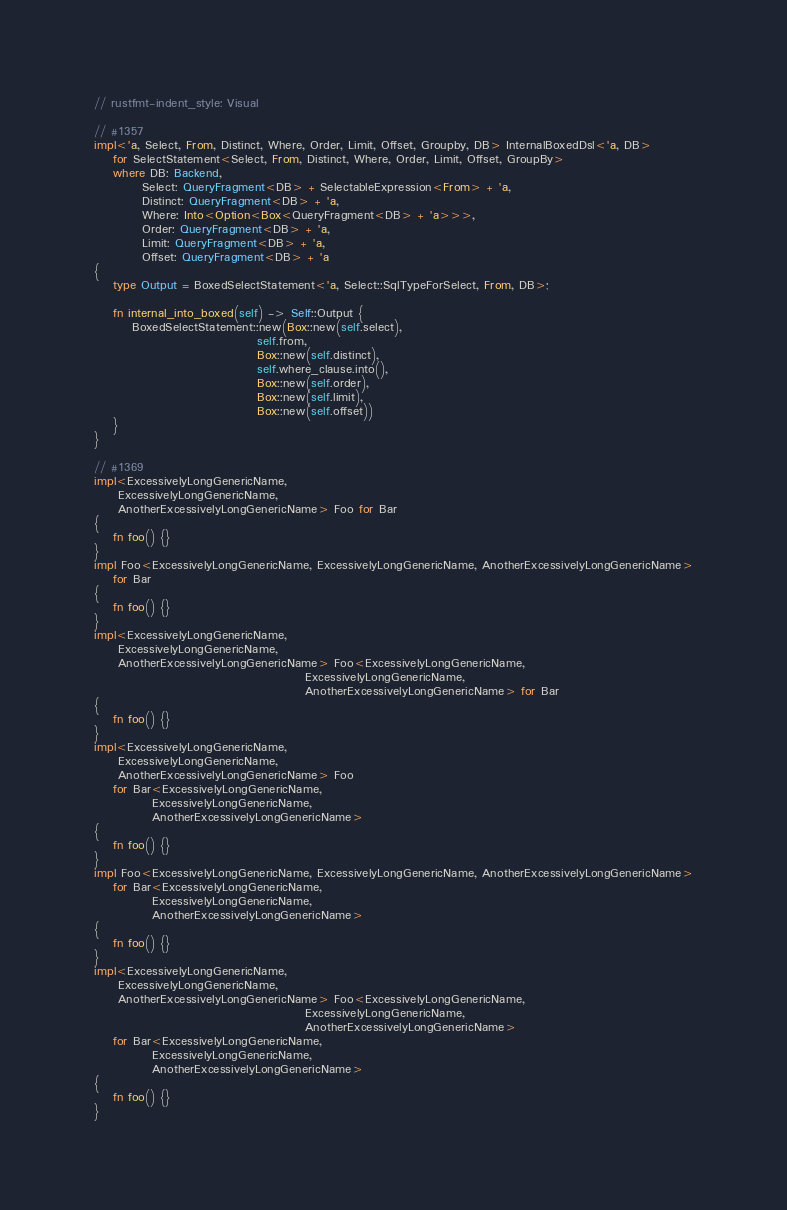<code> <loc_0><loc_0><loc_500><loc_500><_Rust_>// rustfmt-indent_style: Visual

// #1357
impl<'a, Select, From, Distinct, Where, Order, Limit, Offset, Groupby, DB> InternalBoxedDsl<'a, DB>
    for SelectStatement<Select, From, Distinct, Where, Order, Limit, Offset, GroupBy>
    where DB: Backend,
          Select: QueryFragment<DB> + SelectableExpression<From> + 'a,
          Distinct: QueryFragment<DB> + 'a,
          Where: Into<Option<Box<QueryFragment<DB> + 'a>>>,
          Order: QueryFragment<DB> + 'a,
          Limit: QueryFragment<DB> + 'a,
          Offset: QueryFragment<DB> + 'a
{
    type Output = BoxedSelectStatement<'a, Select::SqlTypeForSelect, From, DB>;

    fn internal_into_boxed(self) -> Self::Output {
        BoxedSelectStatement::new(Box::new(self.select),
                                  self.from,
                                  Box::new(self.distinct),
                                  self.where_clause.into(),
                                  Box::new(self.order),
                                  Box::new(self.limit),
                                  Box::new(self.offset))
    }
}

// #1369
impl<ExcessivelyLongGenericName,
     ExcessivelyLongGenericName,
     AnotherExcessivelyLongGenericName> Foo for Bar
{
    fn foo() {}
}
impl Foo<ExcessivelyLongGenericName, ExcessivelyLongGenericName, AnotherExcessivelyLongGenericName>
    for Bar
{
    fn foo() {}
}
impl<ExcessivelyLongGenericName,
     ExcessivelyLongGenericName,
     AnotherExcessivelyLongGenericName> Foo<ExcessivelyLongGenericName,
                                            ExcessivelyLongGenericName,
                                            AnotherExcessivelyLongGenericName> for Bar
{
    fn foo() {}
}
impl<ExcessivelyLongGenericName,
     ExcessivelyLongGenericName,
     AnotherExcessivelyLongGenericName> Foo
    for Bar<ExcessivelyLongGenericName,
            ExcessivelyLongGenericName,
            AnotherExcessivelyLongGenericName>
{
    fn foo() {}
}
impl Foo<ExcessivelyLongGenericName, ExcessivelyLongGenericName, AnotherExcessivelyLongGenericName>
    for Bar<ExcessivelyLongGenericName,
            ExcessivelyLongGenericName,
            AnotherExcessivelyLongGenericName>
{
    fn foo() {}
}
impl<ExcessivelyLongGenericName,
     ExcessivelyLongGenericName,
     AnotherExcessivelyLongGenericName> Foo<ExcessivelyLongGenericName,
                                            ExcessivelyLongGenericName,
                                            AnotherExcessivelyLongGenericName>
    for Bar<ExcessivelyLongGenericName,
            ExcessivelyLongGenericName,
            AnotherExcessivelyLongGenericName>
{
    fn foo() {}
}
</code> 